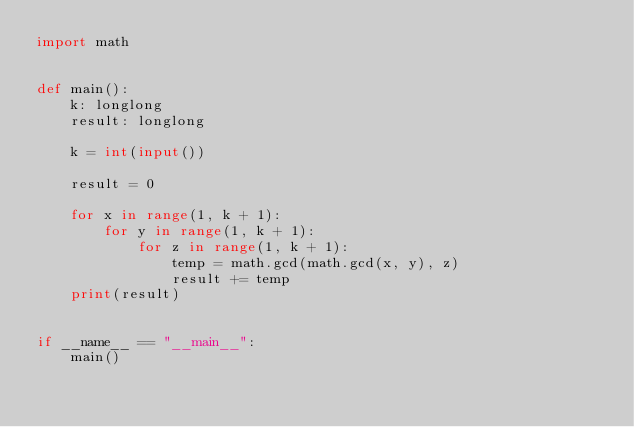Convert code to text. <code><loc_0><loc_0><loc_500><loc_500><_Python_>import math


def main():
    k: longlong
    result: longlong

    k = int(input())

    result = 0

    for x in range(1, k + 1):
        for y in range(1, k + 1):
            for z in range(1, k + 1):
                temp = math.gcd(math.gcd(x, y), z)
                result += temp
    print(result)


if __name__ == "__main__":
    main()
</code> 